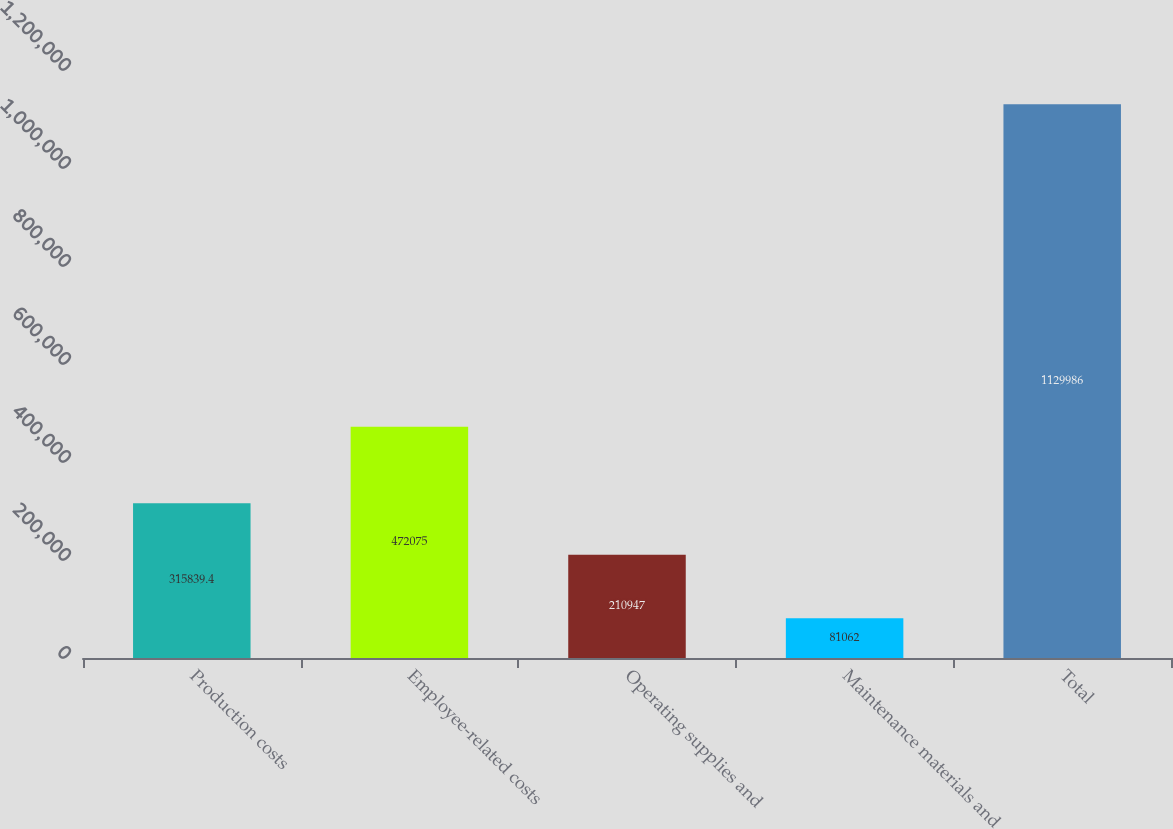Convert chart. <chart><loc_0><loc_0><loc_500><loc_500><bar_chart><fcel>Production costs<fcel>Employee-related costs<fcel>Operating supplies and<fcel>Maintenance materials and<fcel>Total<nl><fcel>315839<fcel>472075<fcel>210947<fcel>81062<fcel>1.12999e+06<nl></chart> 